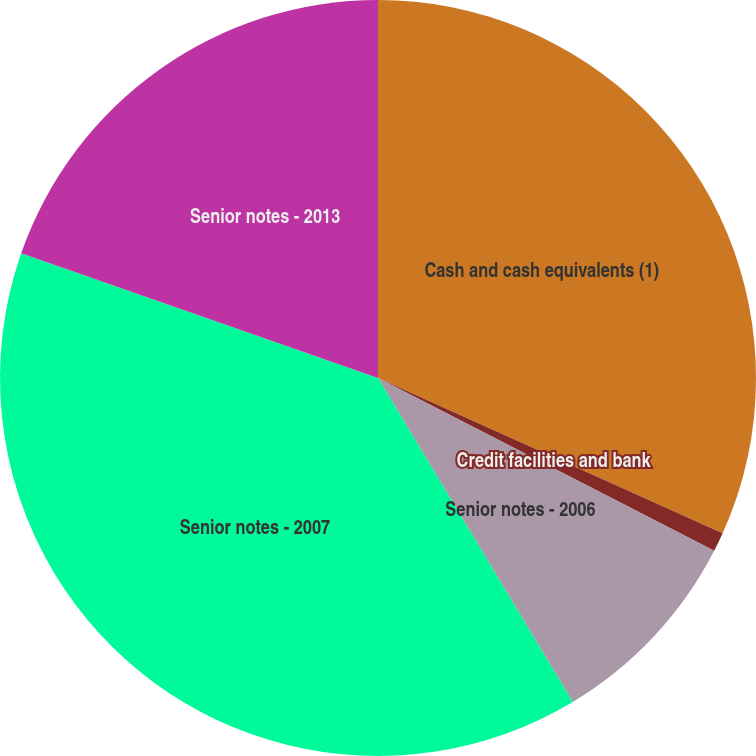Convert chart. <chart><loc_0><loc_0><loc_500><loc_500><pie_chart><fcel>Cash and cash equivalents (1)<fcel>Credit facilities and bank<fcel>Senior notes - 2006<fcel>Senior notes - 2007<fcel>Senior notes - 2013<nl><fcel>31.74%<fcel>0.82%<fcel>8.83%<fcel>38.97%<fcel>19.65%<nl></chart> 